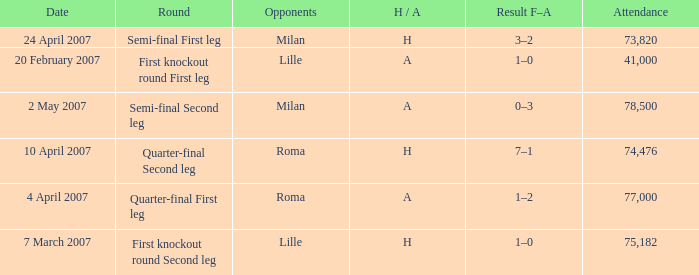Which round has Attendance larger than 41,000, a H/A of A, and a Result F–A of 1–2? Quarter-final First leg. 